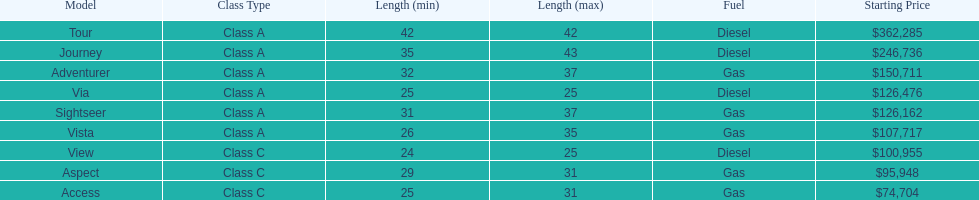How many models are available in lengths longer than 30 feet? 7. 